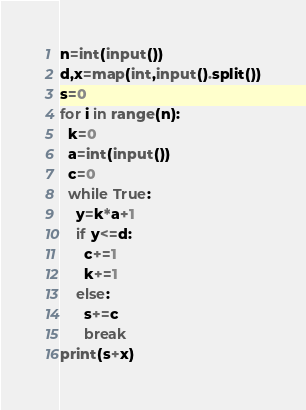Convert code to text. <code><loc_0><loc_0><loc_500><loc_500><_Python_>n=int(input())
d,x=map(int,input().split())
s=0
for i in range(n):
  k=0
  a=int(input())
  c=0
  while True:
    y=k*a+1
    if y<=d:
      c+=1
      k+=1
    else:
      s+=c
      break
print(s+x)
</code> 